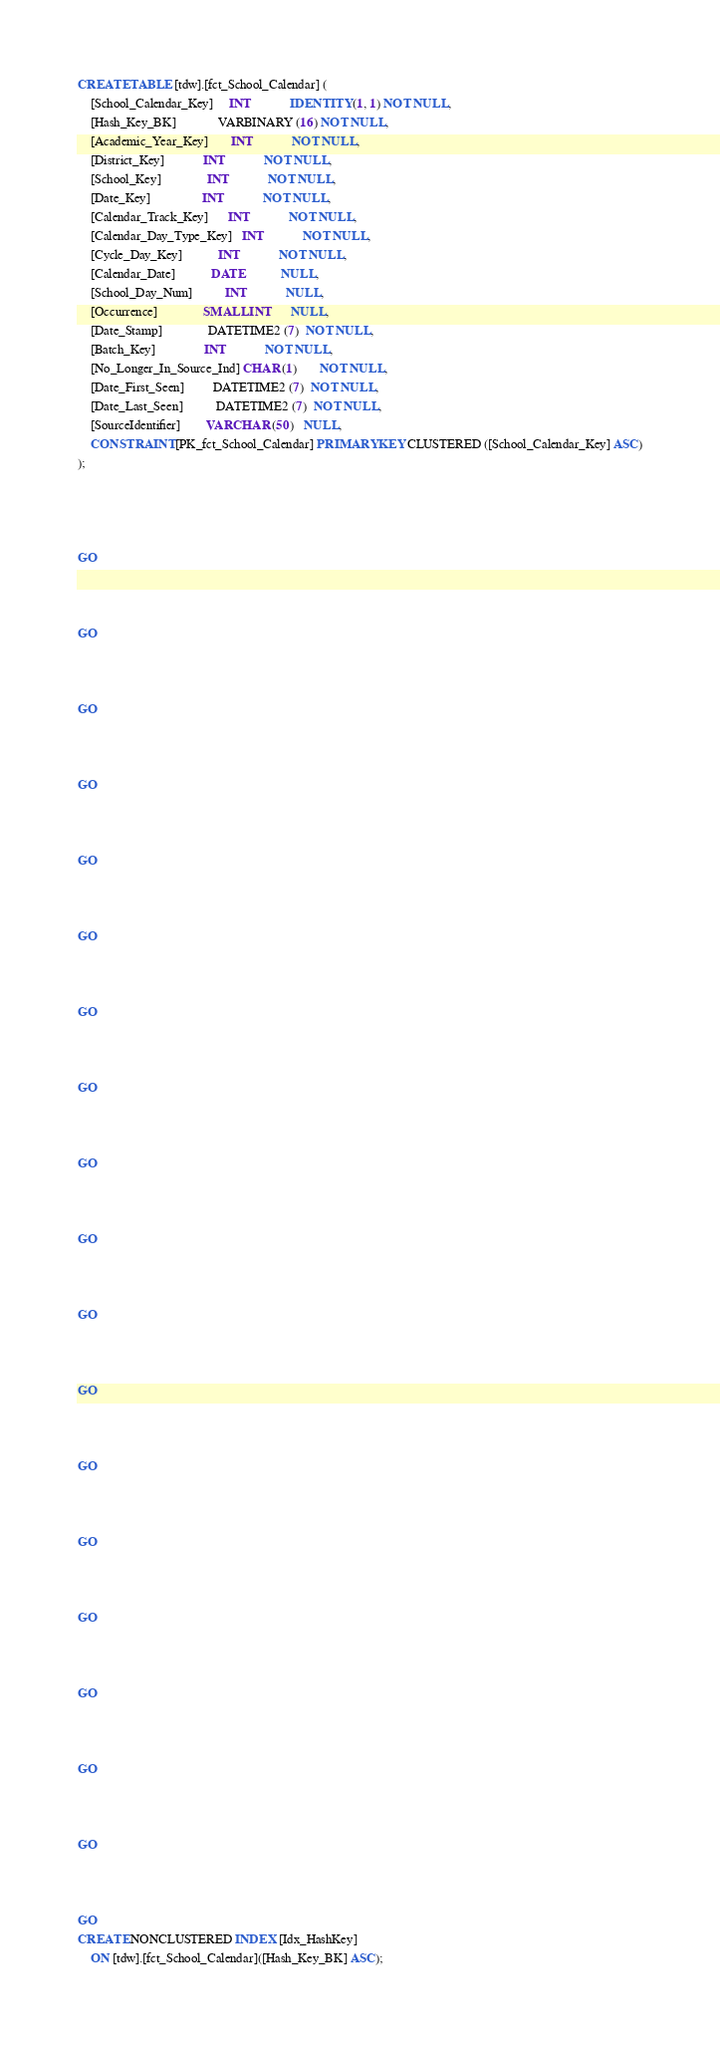Convert code to text. <code><loc_0><loc_0><loc_500><loc_500><_SQL_>CREATE TABLE [tdw].[fct_School_Calendar] (
    [School_Calendar_Key]     INT            IDENTITY (1, 1) NOT NULL,
    [Hash_Key_BK]             VARBINARY (16) NOT NULL,
    [Academic_Year_Key]       INT            NOT NULL,
    [District_Key]            INT            NOT NULL,
    [School_Key]              INT            NOT NULL,
    [Date_Key]                INT            NOT NULL,
    [Calendar_Track_Key]      INT            NOT NULL,
    [Calendar_Day_Type_Key]   INT            NOT NULL,
    [Cycle_Day_Key]           INT            NOT NULL,
    [Calendar_Date]           DATE           NULL,
    [School_Day_Num]          INT            NULL,
    [Occurrence]              SMALLINT       NULL,
    [Date_Stamp]              DATETIME2 (7)  NOT NULL,
    [Batch_Key]               INT            NOT NULL,
    [No_Longer_In_Source_Ind] CHAR (1)       NOT NULL,
    [Date_First_Seen]         DATETIME2 (7)  NOT NULL,
    [Date_Last_Seen]          DATETIME2 (7)  NOT NULL,
    [SourceIdentifier]        VARCHAR (50)   NULL,
    CONSTRAINT [PK_fct_School_Calendar] PRIMARY KEY CLUSTERED ([School_Calendar_Key] ASC)
);




GO



GO



GO



GO



GO



GO



GO



GO



GO



GO



GO



GO



GO



GO



GO



GO



GO



GO



GO
CREATE NONCLUSTERED INDEX [Idx_HashKey]
    ON [tdw].[fct_School_Calendar]([Hash_Key_BK] ASC);

</code> 